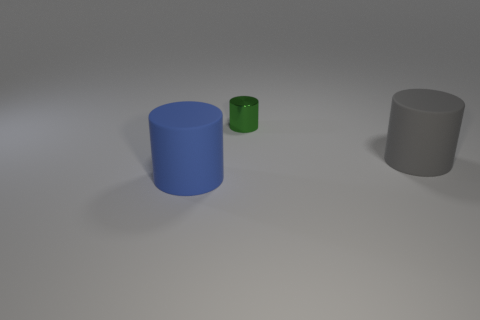There is a matte cylinder that is right of the matte object left of the big gray rubber cylinder; how big is it?
Give a very brief answer. Large. What number of objects are tiny cyan shiny spheres or big objects?
Offer a terse response. 2. Is there another shiny object that has the same color as the tiny metal object?
Your answer should be very brief. No. Is the number of large blue objects less than the number of big matte cylinders?
Provide a succinct answer. Yes. How many things are big brown spheres or matte things that are on the right side of the tiny cylinder?
Ensure brevity in your answer.  1. Is there another tiny thing that has the same material as the blue thing?
Provide a short and direct response. No. There is another cylinder that is the same size as the gray cylinder; what is it made of?
Give a very brief answer. Rubber. The large cylinder that is left of the large matte cylinder behind the large blue cylinder is made of what material?
Give a very brief answer. Rubber. There is a big matte object that is to the left of the tiny green cylinder; does it have the same shape as the green thing?
Offer a very short reply. Yes. There is a cylinder that is made of the same material as the gray thing; what color is it?
Your answer should be very brief. Blue. 